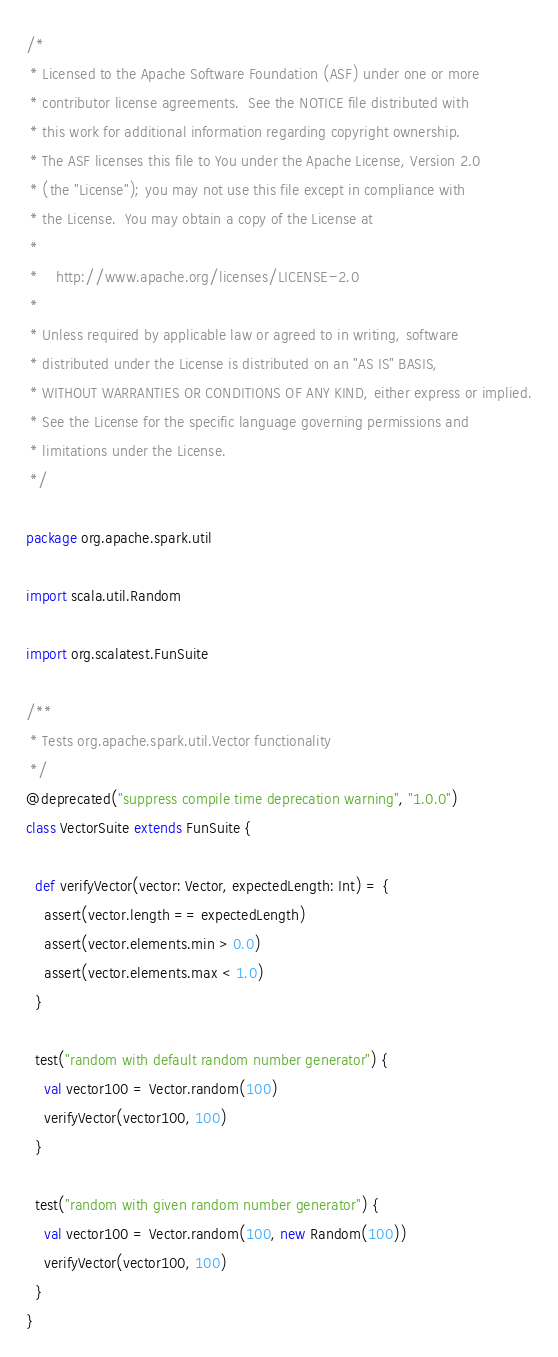<code> <loc_0><loc_0><loc_500><loc_500><_Scala_>/*
 * Licensed to the Apache Software Foundation (ASF) under one or more
 * contributor license agreements.  See the NOTICE file distributed with
 * this work for additional information regarding copyright ownership.
 * The ASF licenses this file to You under the Apache License, Version 2.0
 * (the "License"); you may not use this file except in compliance with
 * the License.  You may obtain a copy of the License at
 *
 *    http://www.apache.org/licenses/LICENSE-2.0
 *
 * Unless required by applicable law or agreed to in writing, software
 * distributed under the License is distributed on an "AS IS" BASIS,
 * WITHOUT WARRANTIES OR CONDITIONS OF ANY KIND, either express or implied.
 * See the License for the specific language governing permissions and
 * limitations under the License.
 */

package org.apache.spark.util

import scala.util.Random

import org.scalatest.FunSuite

/**
 * Tests org.apache.spark.util.Vector functionality
 */
@deprecated("suppress compile time deprecation warning", "1.0.0")
class VectorSuite extends FunSuite {

  def verifyVector(vector: Vector, expectedLength: Int) = {
    assert(vector.length == expectedLength)
    assert(vector.elements.min > 0.0)
    assert(vector.elements.max < 1.0)
  }

  test("random with default random number generator") {
    val vector100 = Vector.random(100)
    verifyVector(vector100, 100)
  }

  test("random with given random number generator") {
    val vector100 = Vector.random(100, new Random(100))
    verifyVector(vector100, 100)
  }
}
</code> 